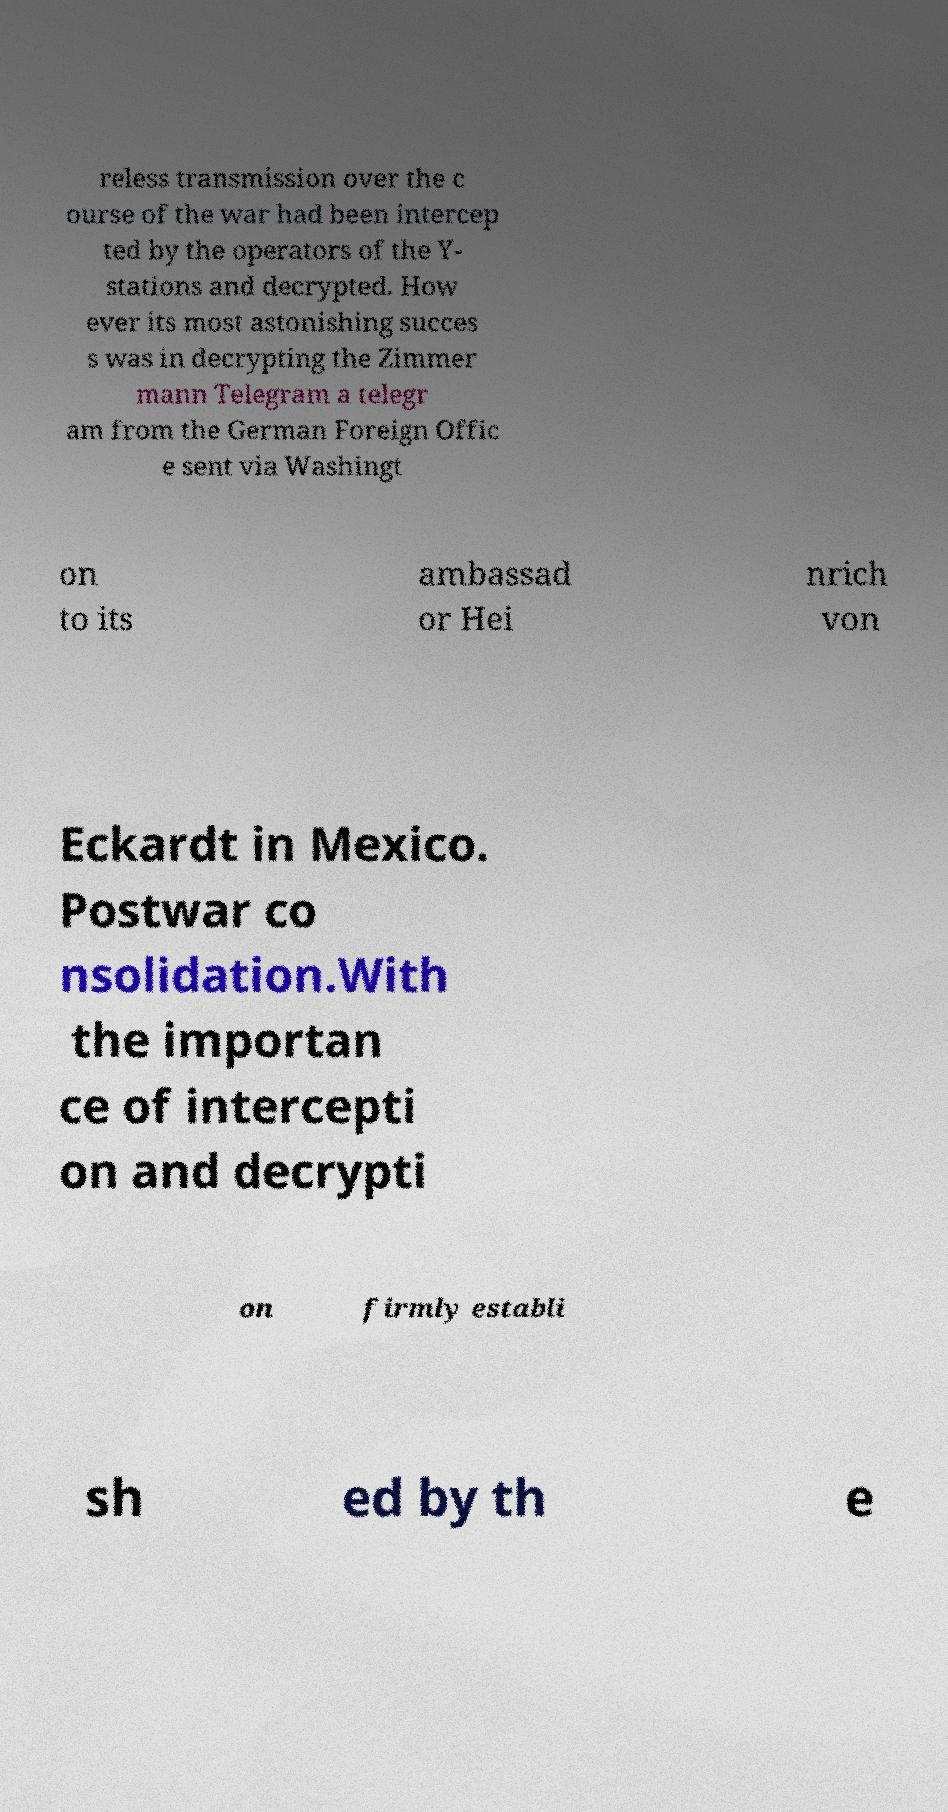What messages or text are displayed in this image? I need them in a readable, typed format. reless transmission over the c ourse of the war had been intercep ted by the operators of the Y- stations and decrypted. How ever its most astonishing succes s was in decrypting the Zimmer mann Telegram a telegr am from the German Foreign Offic e sent via Washingt on to its ambassad or Hei nrich von Eckardt in Mexico. Postwar co nsolidation.With the importan ce of intercepti on and decrypti on firmly establi sh ed by th e 